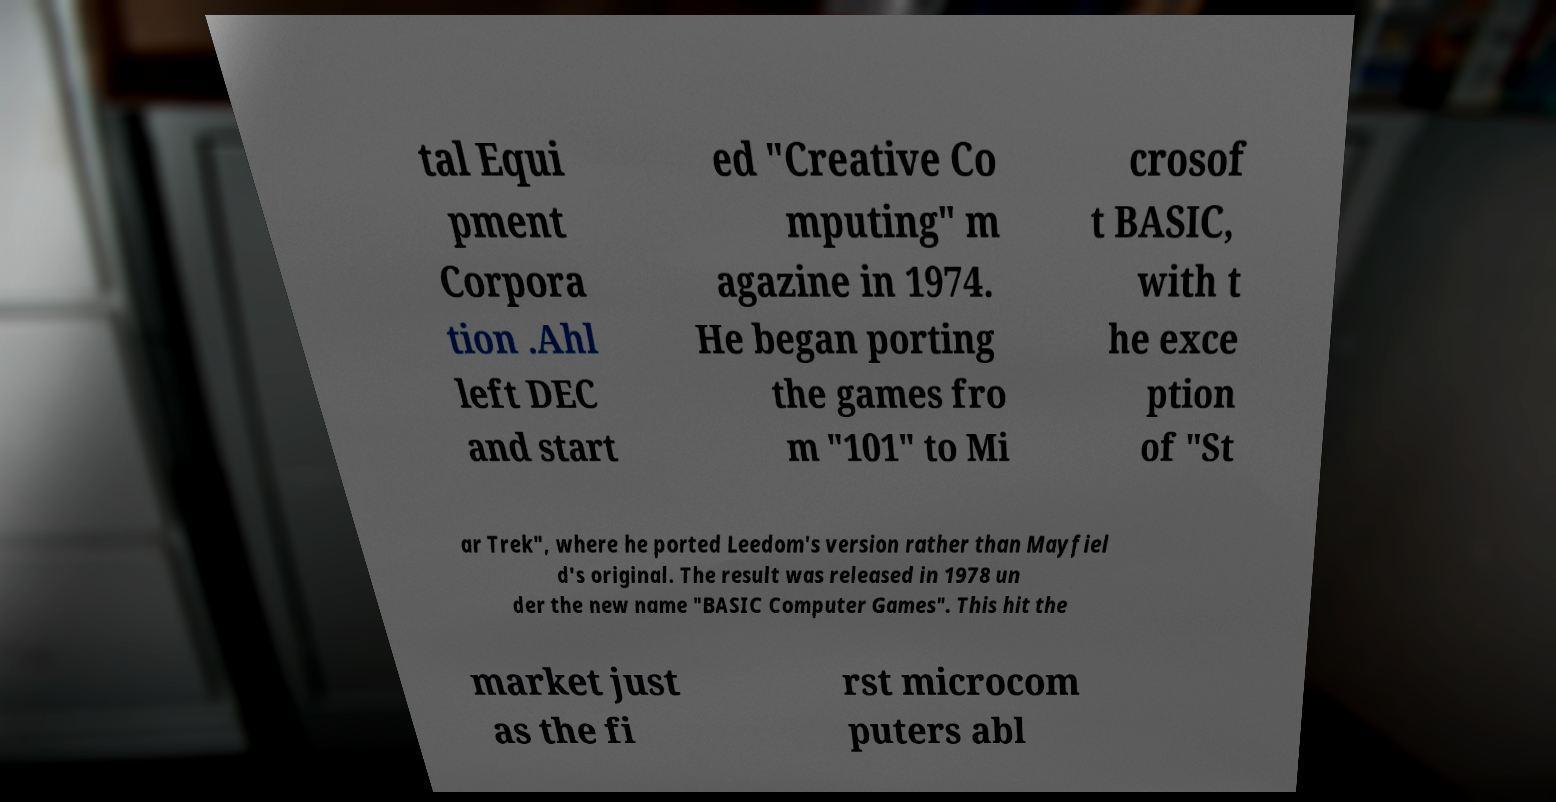For documentation purposes, I need the text within this image transcribed. Could you provide that? tal Equi pment Corpora tion .Ahl left DEC and start ed "Creative Co mputing" m agazine in 1974. He began porting the games fro m "101" to Mi crosof t BASIC, with t he exce ption of "St ar Trek", where he ported Leedom's version rather than Mayfiel d's original. The result was released in 1978 un der the new name "BASIC Computer Games". This hit the market just as the fi rst microcom puters abl 